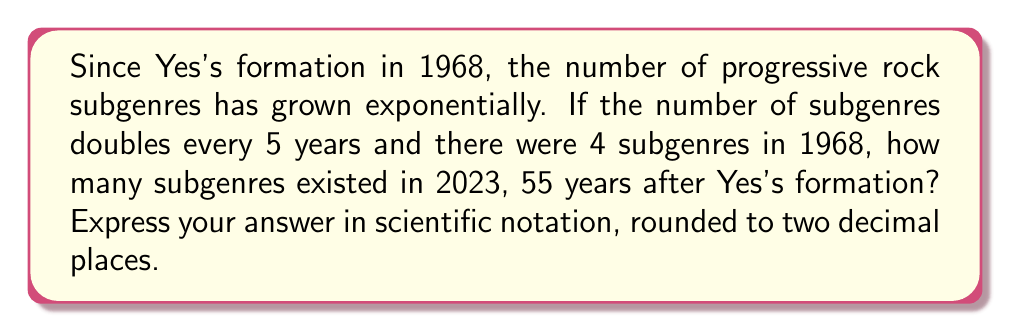Can you answer this question? Let's approach this step-by-step:

1) We start with 4 subgenres in 1968.

2) The number of subgenres doubles every 5 years.

3) We need to calculate how many times the number doubled in 55 years:
   $\frac{55 \text{ years}}{5 \text{ years per doubling}} = 11$ doublings

4) We can express this as an exponential function:
   $4 \cdot 2^{11}$

5) Let's calculate this:
   $4 \cdot 2^{11} = 4 \cdot 2048 = 8192$

6) To express this in scientific notation, we move the decimal point to the left until we have a number between 1 and 10, and then count how many places we moved:
   $8192 = 8.192 \cdot 10^3$

7) Rounding to two decimal places:
   $8.19 \cdot 10^3$
Answer: $8.19 \cdot 10^3$ 